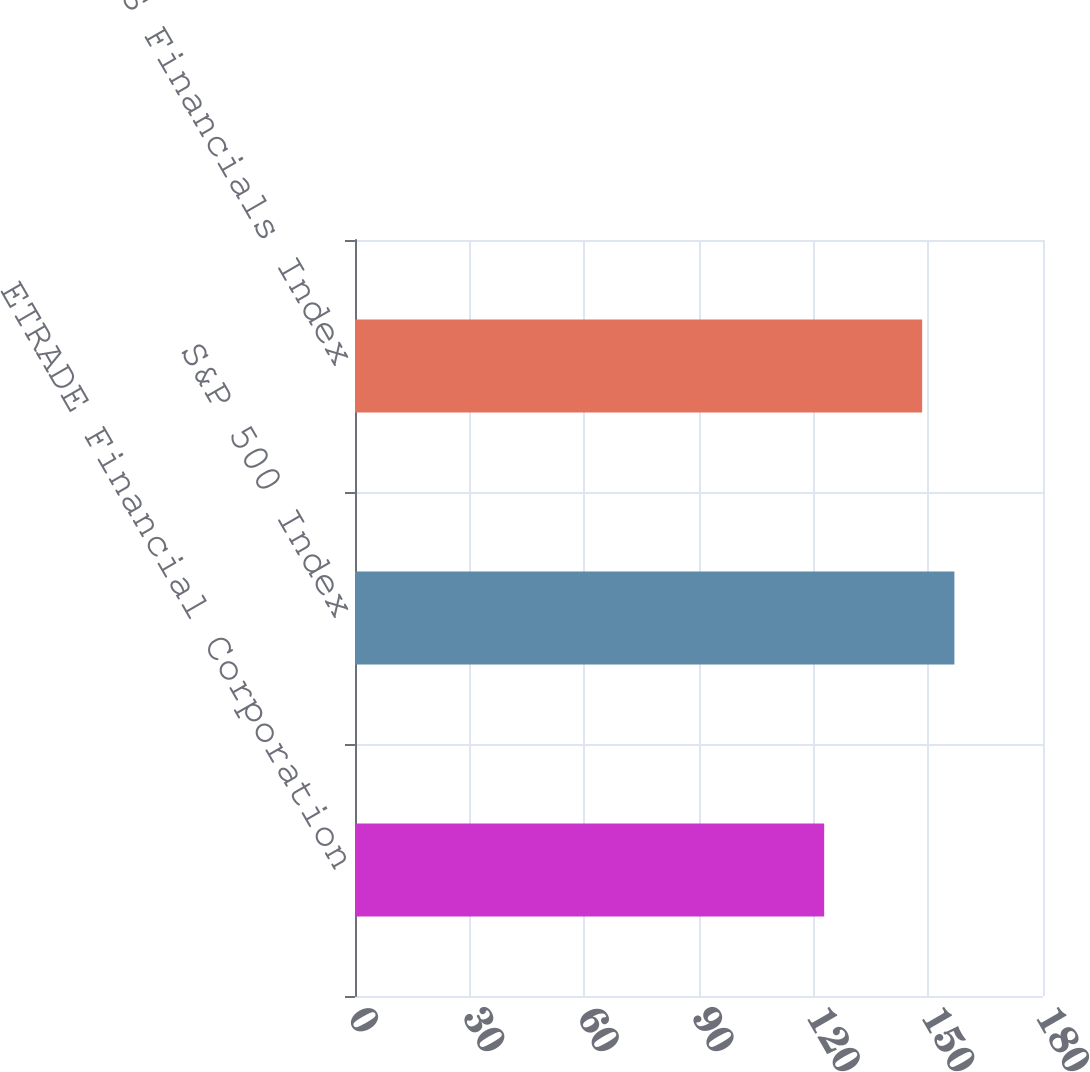Convert chart. <chart><loc_0><loc_0><loc_500><loc_500><bar_chart><fcel>ETRADE Financial Corporation<fcel>S&P 500 Index<fcel>Dow Jones US Financials Index<nl><fcel>122.75<fcel>156.82<fcel>148.39<nl></chart> 